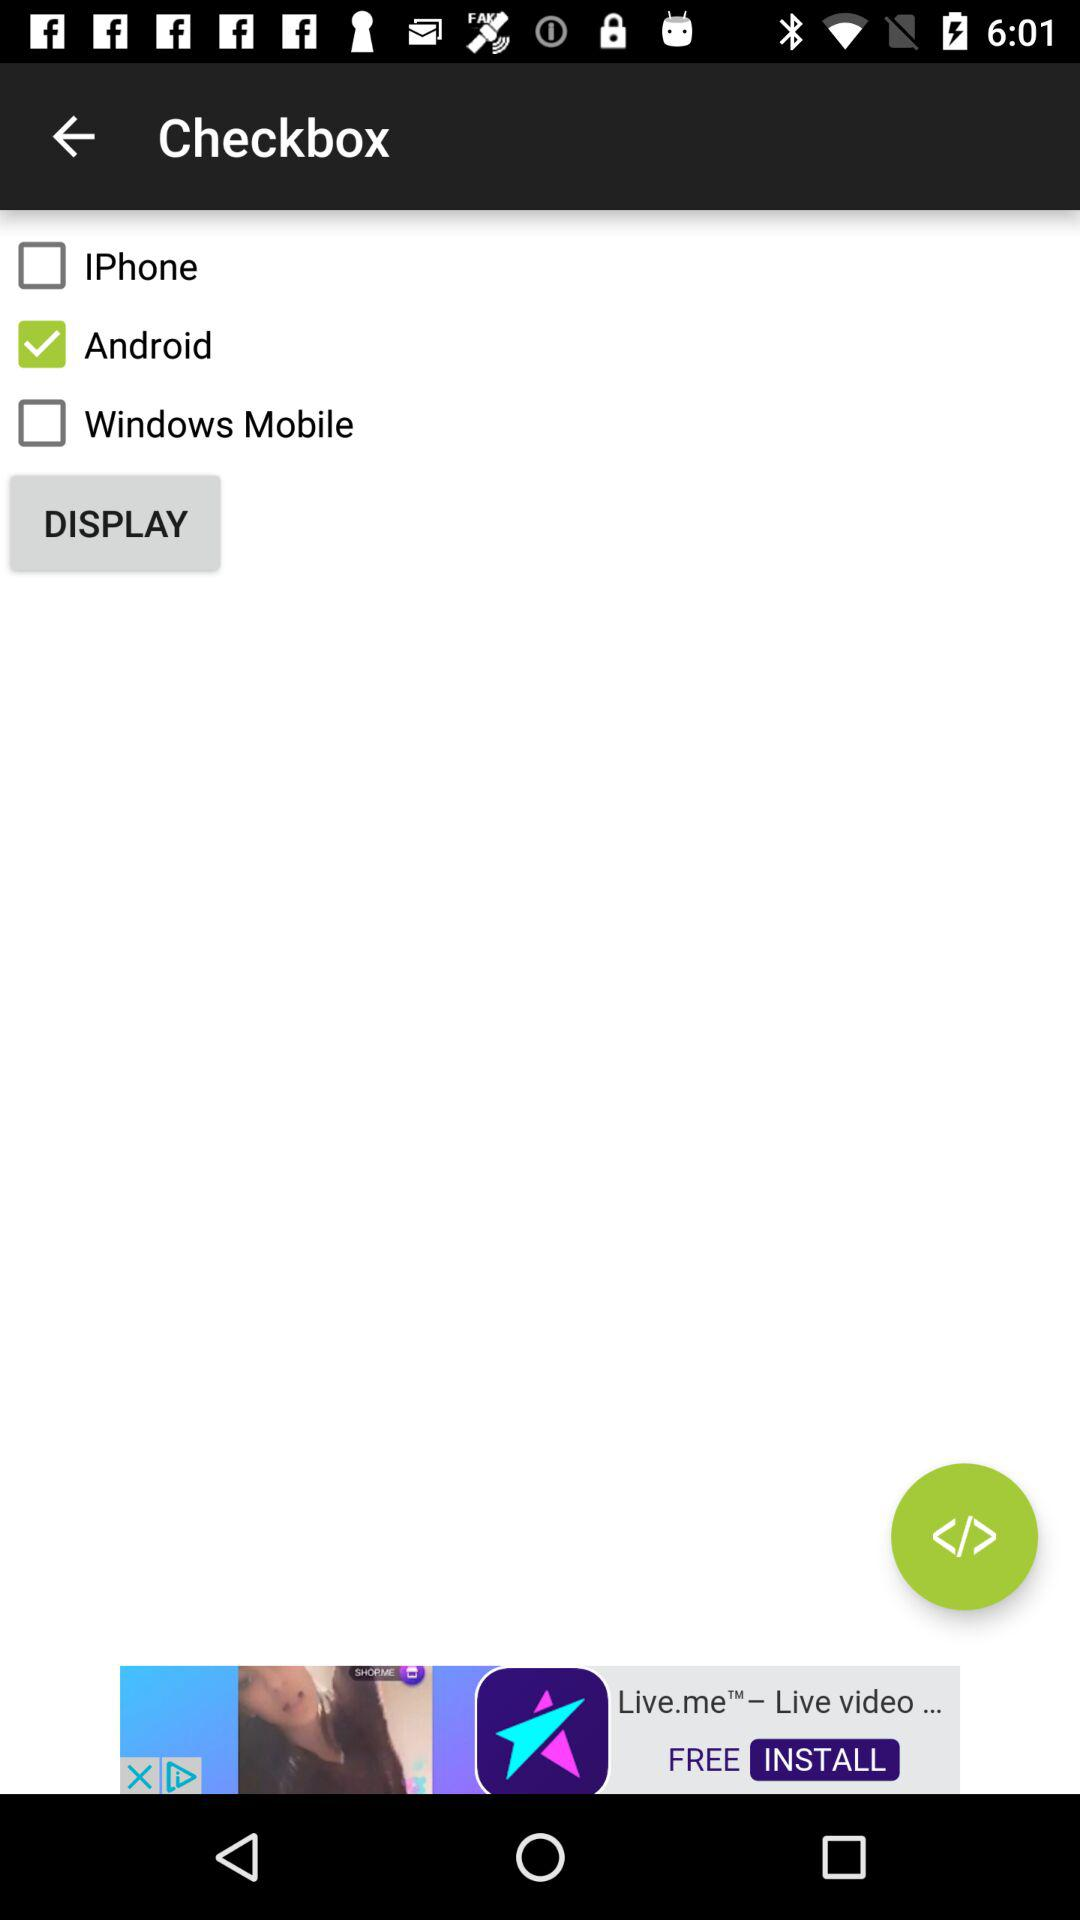What are the options given in "Checkbox"? The options given in "Checkbox" are "IPhone", "Android" and "Windows Mobile". 